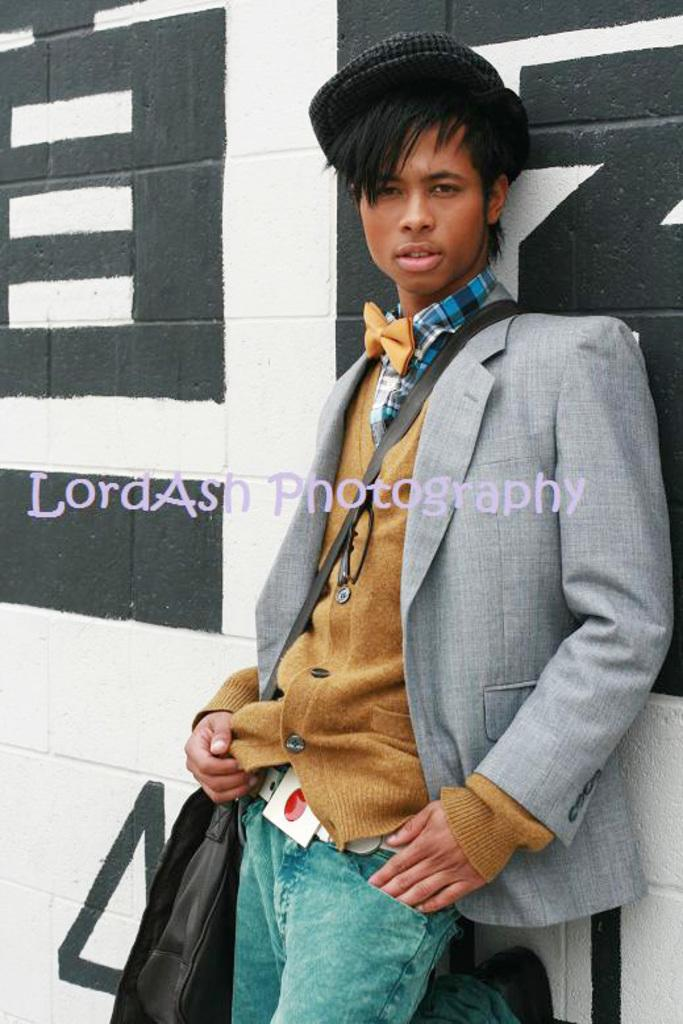What is the main subject of the image? There is a man in the image. What is the man wearing on his upper body? The man is wearing a yellow shirt and a grey suit over it. What color are the man's pants? The man is wearing green jeans. What is the background of the image? The man is standing in front of a wall. Can you see any roses growing on the wall behind the man in the image? There are no roses visible in the image; the man is standing in front of a wall with no visible plants or flowers. 